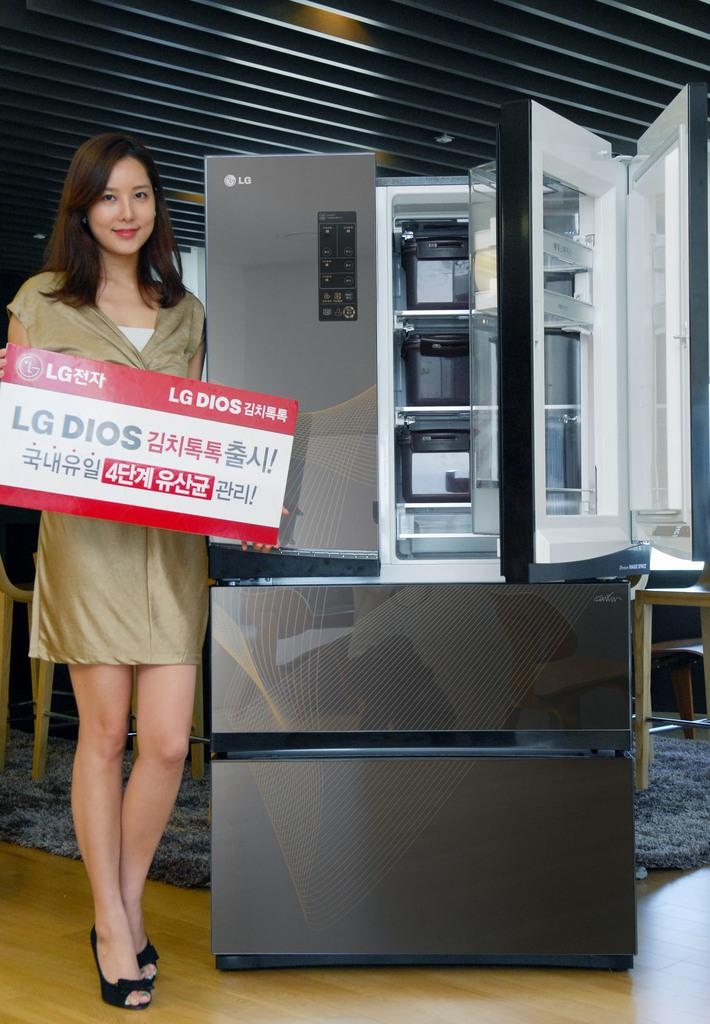<image>
Offer a succinct explanation of the picture presented. A model stands in front of an silver LG refrigerator. 